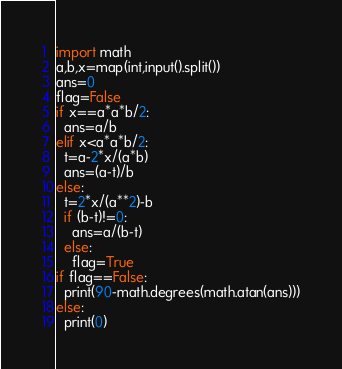<code> <loc_0><loc_0><loc_500><loc_500><_Python_>import math
a,b,x=map(int,input().split())
ans=0
flag=False
if x==a*a*b/2:
  ans=a/b
elif x<a*a*b/2:
  t=a-2*x/(a*b)
  ans=(a-t)/b
else:
  t=2*x/(a**2)-b
  if (b-t)!=0:
    ans=a/(b-t)
  else:
    flag=True
if flag==False:
  print(90-math.degrees(math.atan(ans)))
else:
  print(0)</code> 